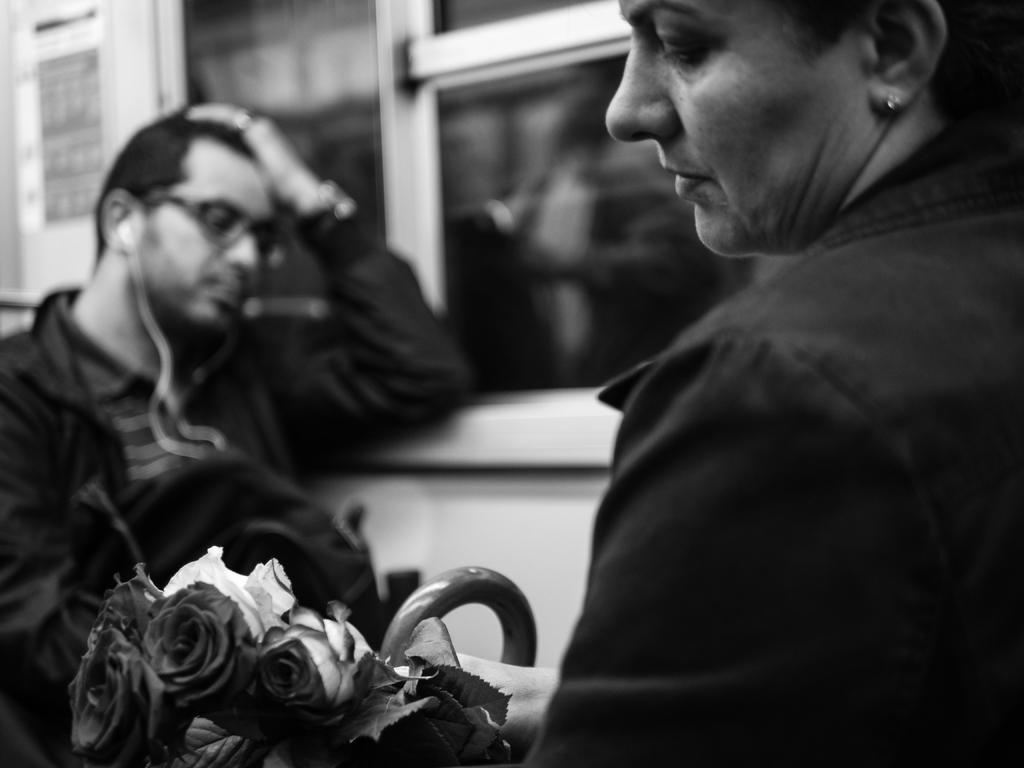What is the color scheme of the image? The image is black and white. Who is present in the image? There is a woman and a man in the image. What is the woman holding in her hands? The woman is holding rose flowers in her hands. Where is the man located in the image? The man is sitting near a window. What type of test can be seen being conducted in the image? There is no test being conducted in the image; it features a woman holding rose flowers and a man sitting near a window. What caption would best describe the image? The image does not have a caption, as it is a still image without any accompanying text. 